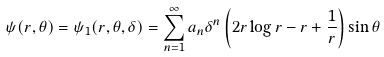<formula> <loc_0><loc_0><loc_500><loc_500>\psi ( r , \theta ) = \psi _ { 1 } ( r , \theta , \delta ) = \sum _ { n = 1 } ^ { \infty } a _ { n } \delta ^ { n } \left ( 2 r \log { r } - r + \frac { 1 } { r } \right ) \sin { \theta }</formula> 